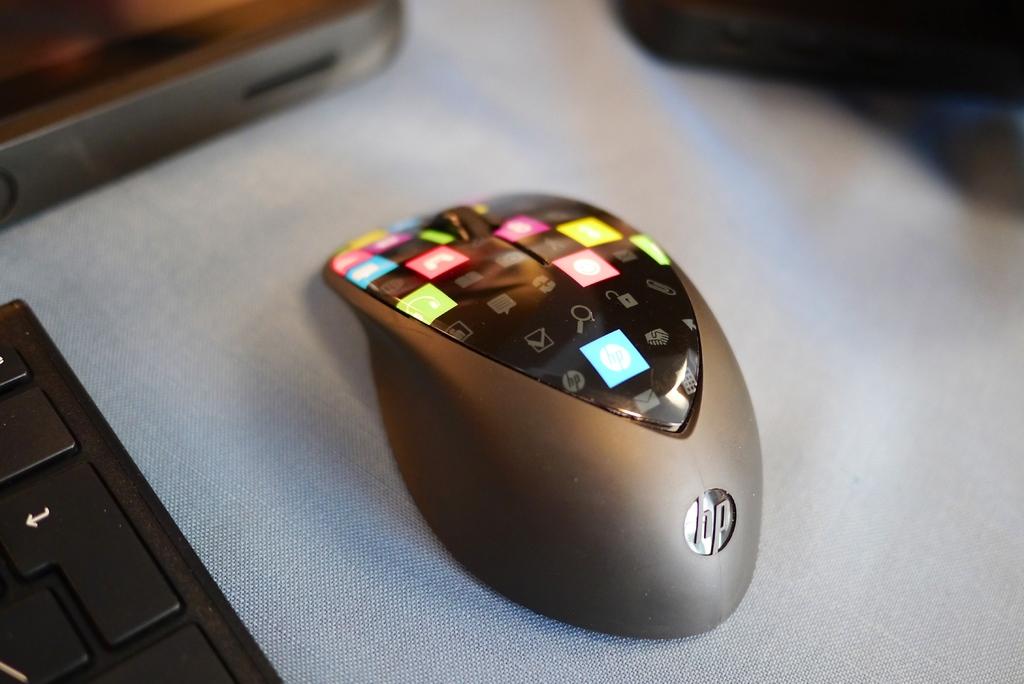What company made this mouse?
Keep it short and to the point. Hp. Is this an hp mouse?
Ensure brevity in your answer.  Yes. 